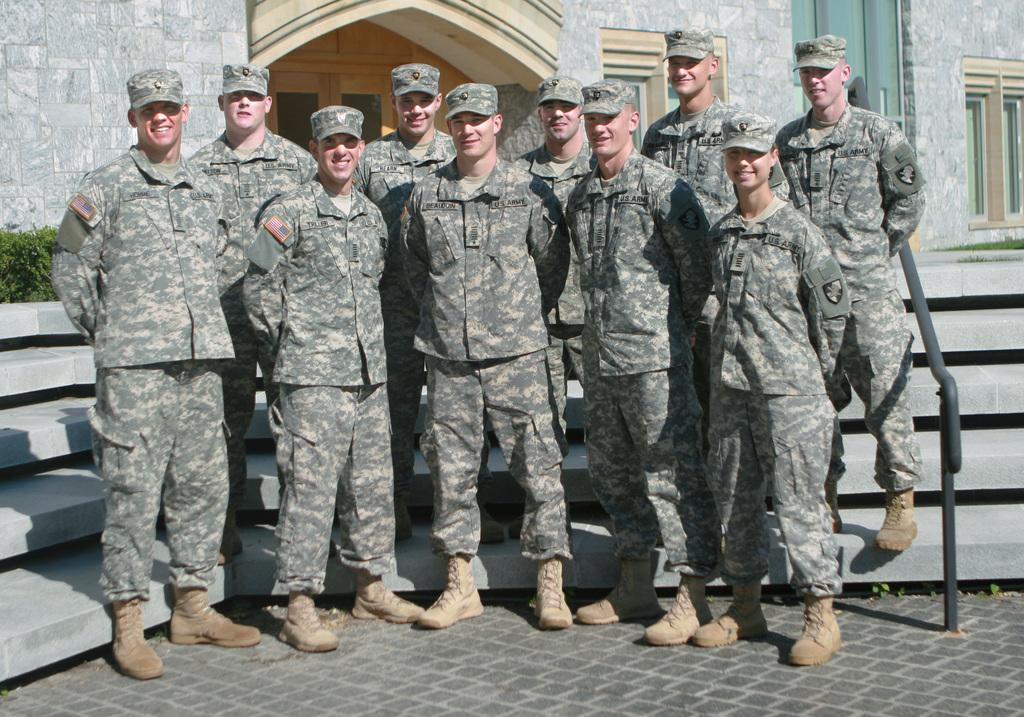What type of people are in the image? There is a group of army officers in the image. Where are the army officers located in the image? The army officers are standing in the middle of the image. What can be seen in the background of the image? There is a building in the background of the image. What architectural feature is present behind the officers in the image? There are steps behind the officers in the image. What type of sticks are being used by the army officers in the image? There are no sticks visible in the image; the army officers are not holding or using any sticks. 